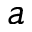Convert formula to latex. <formula><loc_0><loc_0><loc_500><loc_500>a</formula> 